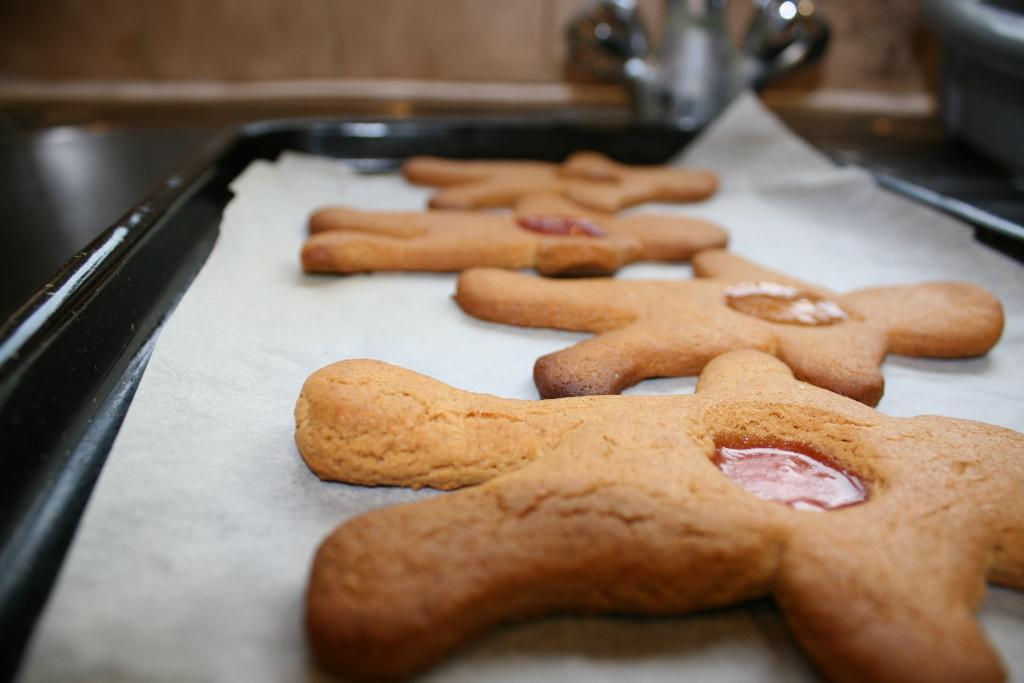What type of food can be seen in the image? The image contains food, but the specific type is not mentioned in the facts. How is the food arranged or presented? The food is in a black color tray. What can be seen in the background of the image? There is a brown color surface in the background of the image. What is attached to the brown color surface? The facts do not specify what is attached to the brown color surface. How many trees are visible in the image? There are no trees visible in the image; the background features a brown color surface. What type of secretary is working in the image? There is no secretary present in the image; it features food in a black color tray and a brown color surface in the background. 